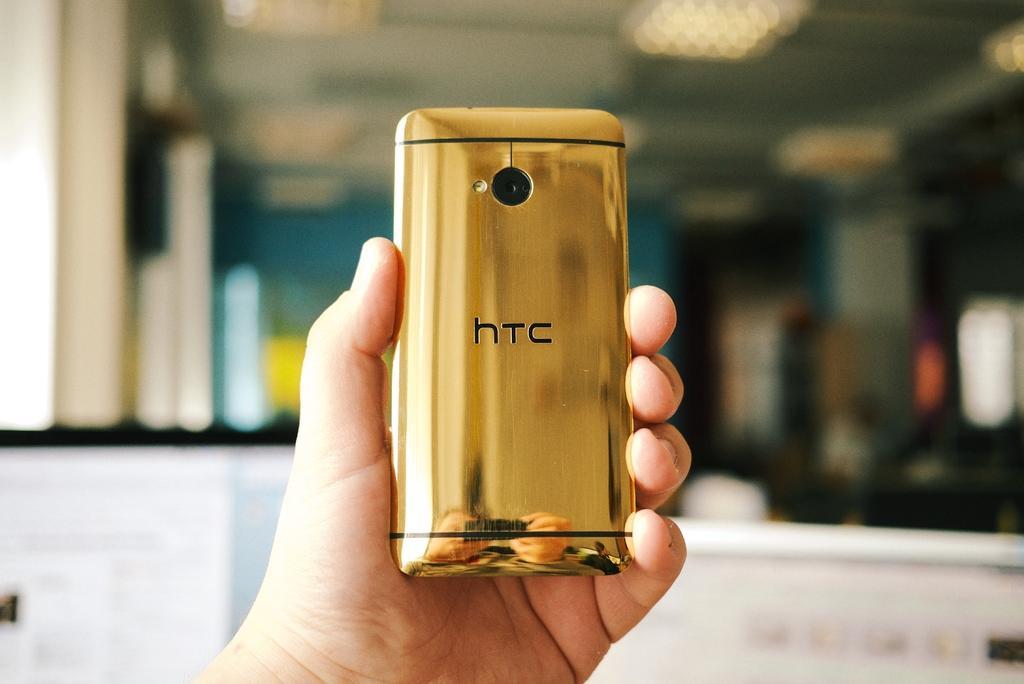Can you describe this image briefly? In this image we can see a human hand is holding a mobile. The background is blurry. 